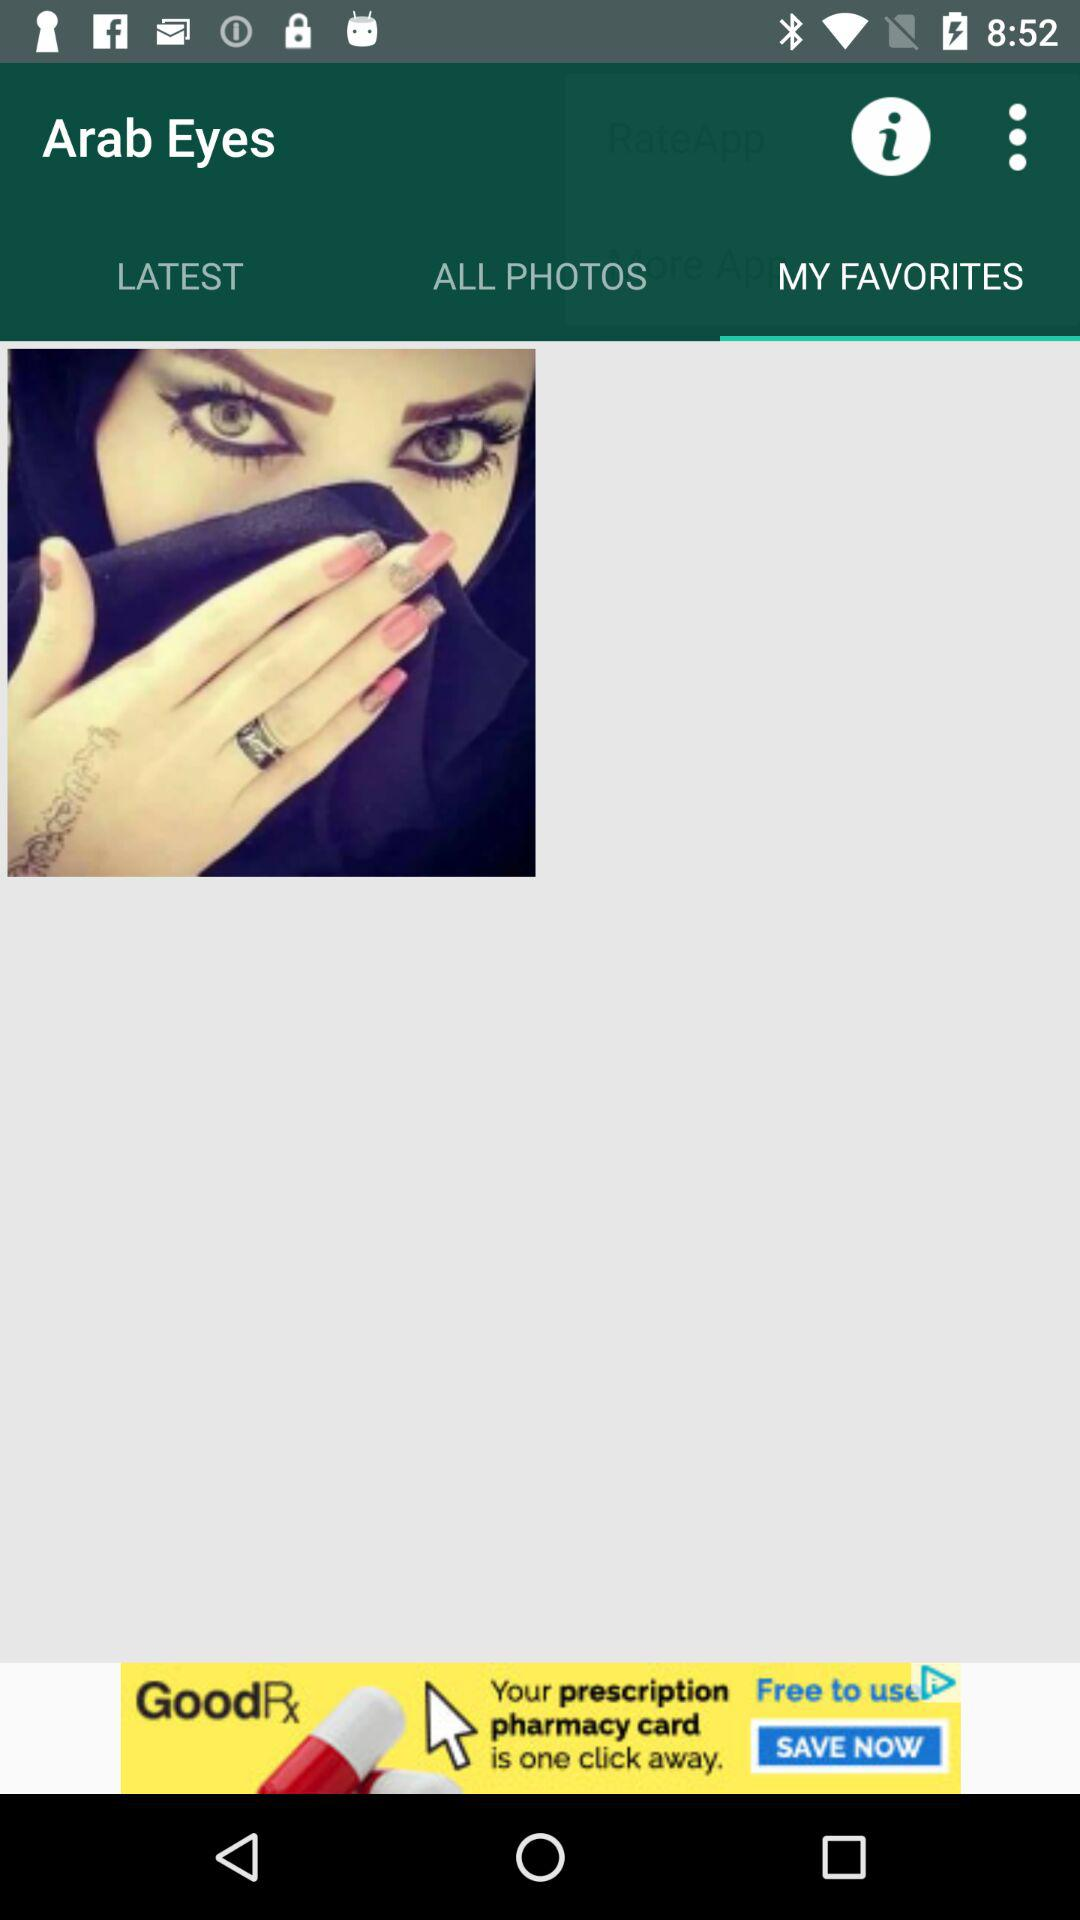What is the application name? The application name is "Arab Eyes". 